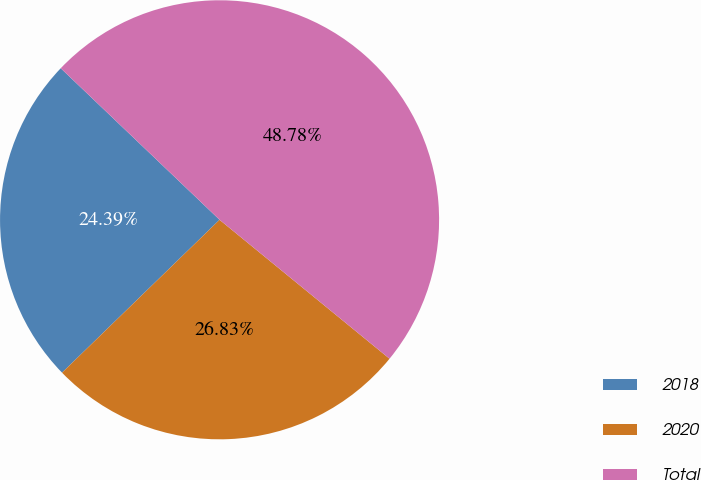Convert chart. <chart><loc_0><loc_0><loc_500><loc_500><pie_chart><fcel>2018<fcel>2020<fcel>Total<nl><fcel>24.39%<fcel>26.83%<fcel>48.78%<nl></chart> 